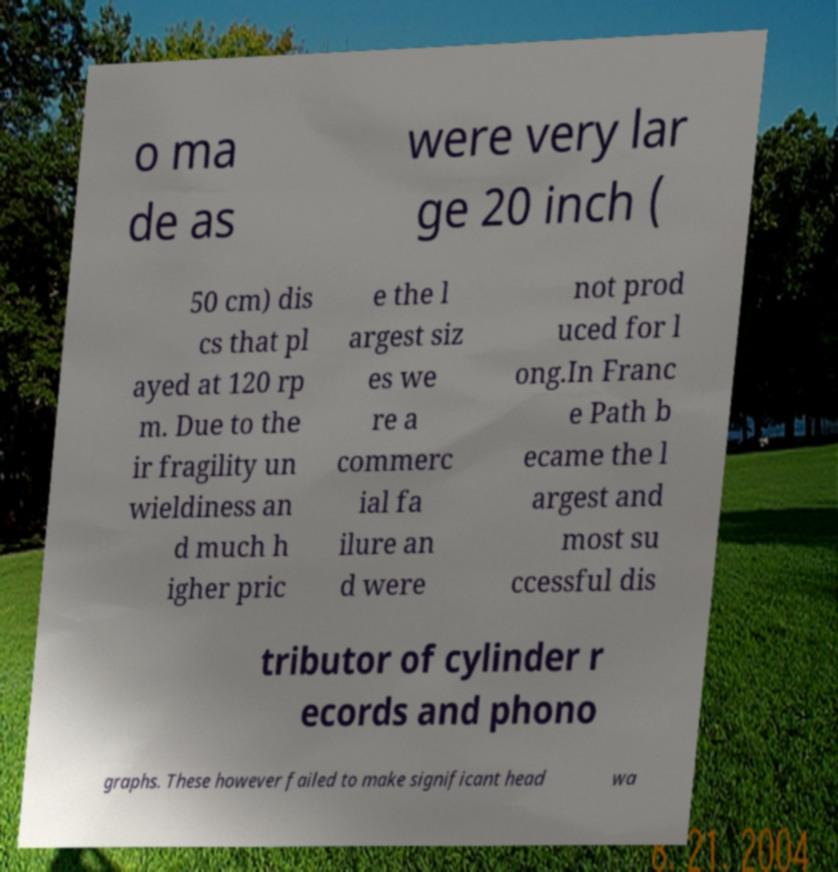Could you assist in decoding the text presented in this image and type it out clearly? o ma de as were very lar ge 20 inch ( 50 cm) dis cs that pl ayed at 120 rp m. Due to the ir fragility un wieldiness an d much h igher pric e the l argest siz es we re a commerc ial fa ilure an d were not prod uced for l ong.In Franc e Path b ecame the l argest and most su ccessful dis tributor of cylinder r ecords and phono graphs. These however failed to make significant head wa 